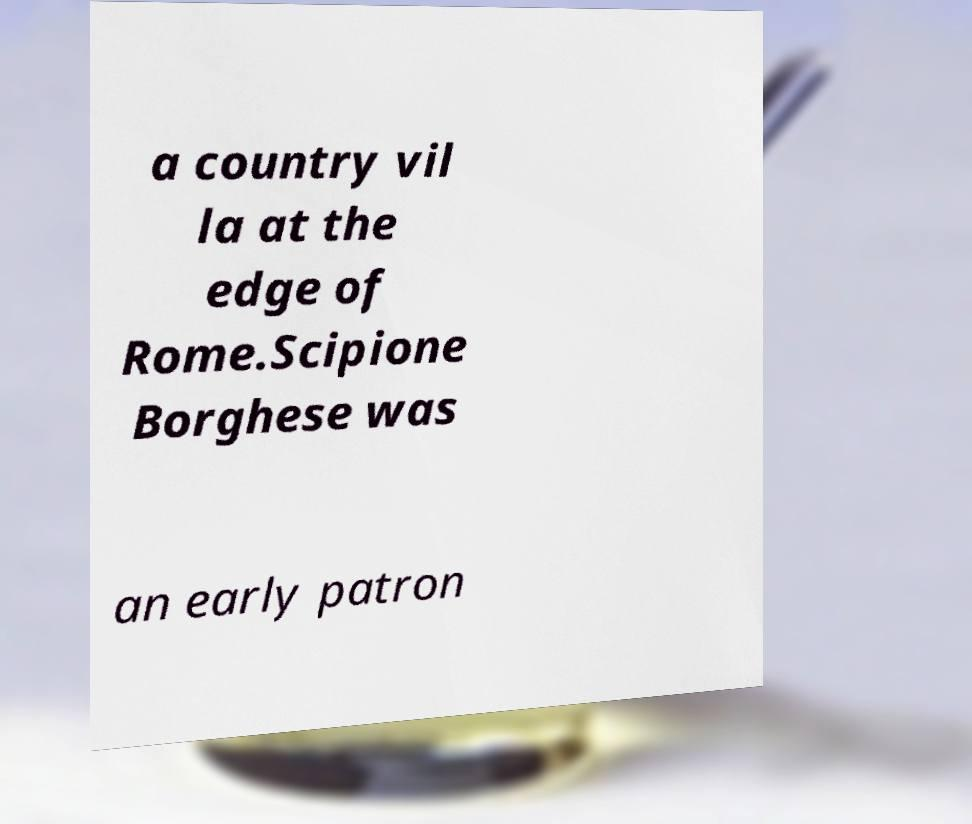Please identify and transcribe the text found in this image. a country vil la at the edge of Rome.Scipione Borghese was an early patron 